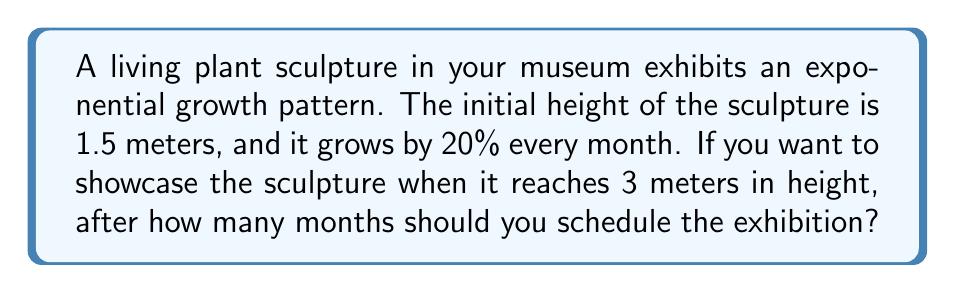Teach me how to tackle this problem. Let's approach this step-by-step:

1) We can model this growth using the exponential function:
   $$h(t) = 1.5 \cdot (1.2)^t$$
   where $h(t)$ is the height in meters after $t$ months.

2) We want to find $t$ when $h(t) = 3$ meters. So, we set up the equation:
   $$3 = 1.5 \cdot (1.2)^t$$

3) Divide both sides by 1.5:
   $$2 = (1.2)^t$$

4) Take the natural logarithm of both sides:
   $$\ln(2) = \ln((1.2)^t)$$

5) Using the logarithm property $\ln(a^b) = b\ln(a)$:
   $$\ln(2) = t \cdot \ln(1.2)$$

6) Solve for $t$:
   $$t = \frac{\ln(2)}{\ln(1.2)} \approx 3.80$$

7) Since we can only schedule in whole months, we need to round up to the next integer.
Answer: 4 months 